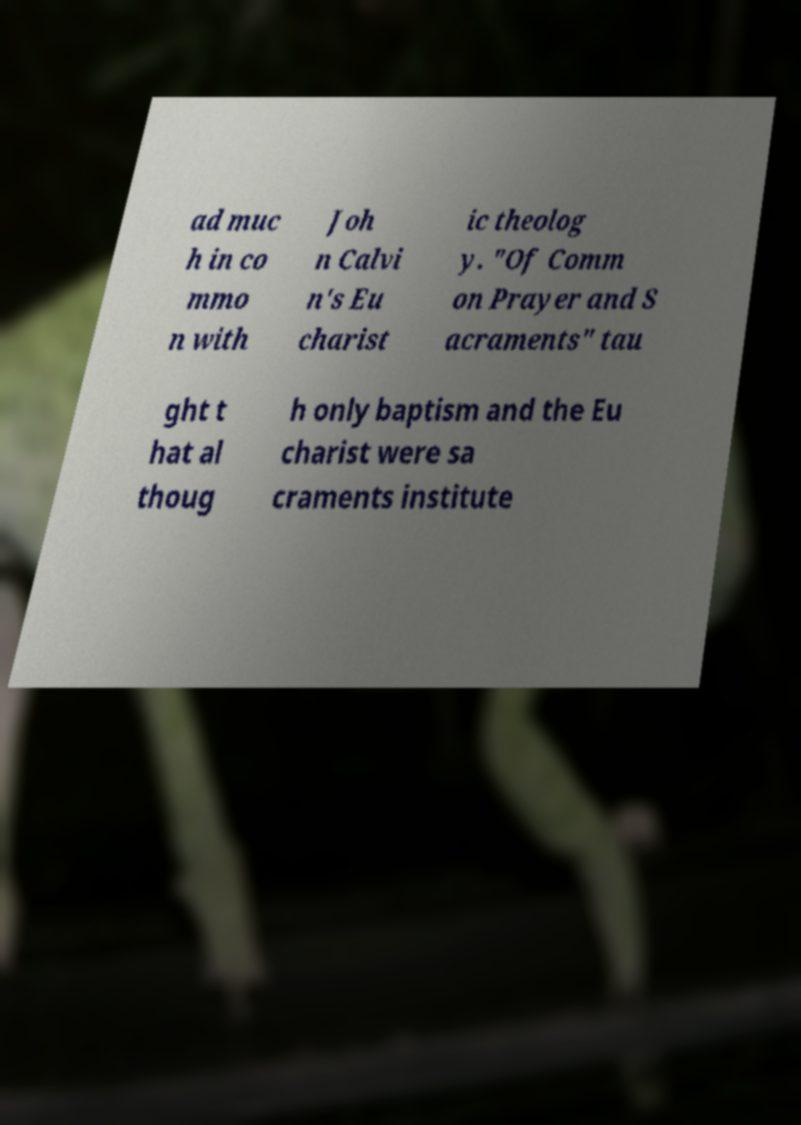Please read and relay the text visible in this image. What does it say? ad muc h in co mmo n with Joh n Calvi n's Eu charist ic theolog y. "Of Comm on Prayer and S acraments" tau ght t hat al thoug h only baptism and the Eu charist were sa craments institute 